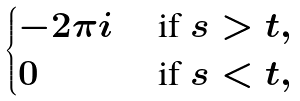Convert formula to latex. <formula><loc_0><loc_0><loc_500><loc_500>\begin{cases} - 2 \pi i & \text { if } s > t , \\ 0 & \text { if } s < t , \quad \end{cases}</formula> 